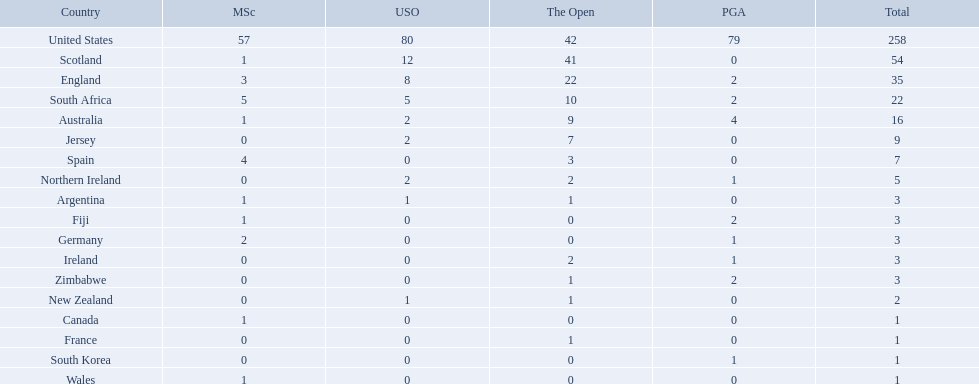What countries in the championship were from africa? South Africa, Zimbabwe. Which of these counteries had the least championship golfers Zimbabwe. 